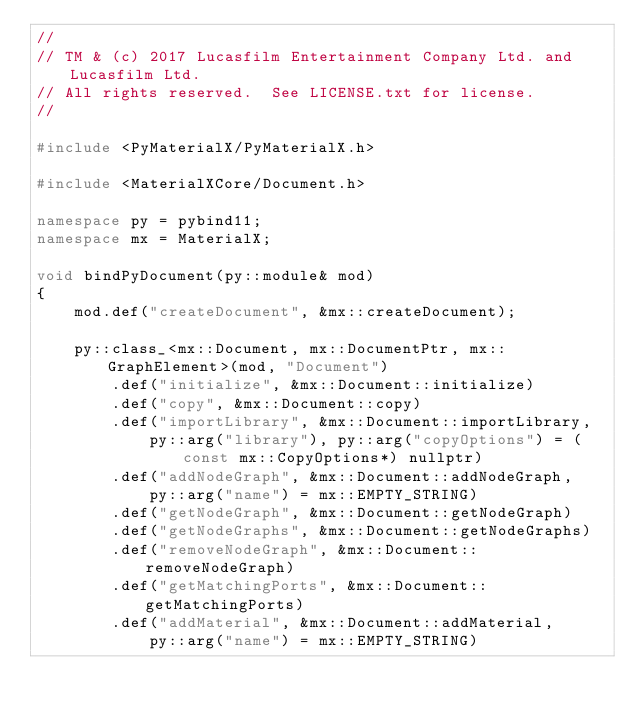Convert code to text. <code><loc_0><loc_0><loc_500><loc_500><_C++_>//
// TM & (c) 2017 Lucasfilm Entertainment Company Ltd. and Lucasfilm Ltd.
// All rights reserved.  See LICENSE.txt for license.
//

#include <PyMaterialX/PyMaterialX.h>

#include <MaterialXCore/Document.h>

namespace py = pybind11;
namespace mx = MaterialX;

void bindPyDocument(py::module& mod)
{
    mod.def("createDocument", &mx::createDocument);

    py::class_<mx::Document, mx::DocumentPtr, mx::GraphElement>(mod, "Document")
        .def("initialize", &mx::Document::initialize)
        .def("copy", &mx::Document::copy)
        .def("importLibrary", &mx::Document::importLibrary, 
            py::arg("library"), py::arg("copyOptions") = (const mx::CopyOptions*) nullptr)
        .def("addNodeGraph", &mx::Document::addNodeGraph,
            py::arg("name") = mx::EMPTY_STRING)
        .def("getNodeGraph", &mx::Document::getNodeGraph)
        .def("getNodeGraphs", &mx::Document::getNodeGraphs)
        .def("removeNodeGraph", &mx::Document::removeNodeGraph)
        .def("getMatchingPorts", &mx::Document::getMatchingPorts)
        .def("addMaterial", &mx::Document::addMaterial,
            py::arg("name") = mx::EMPTY_STRING)</code> 